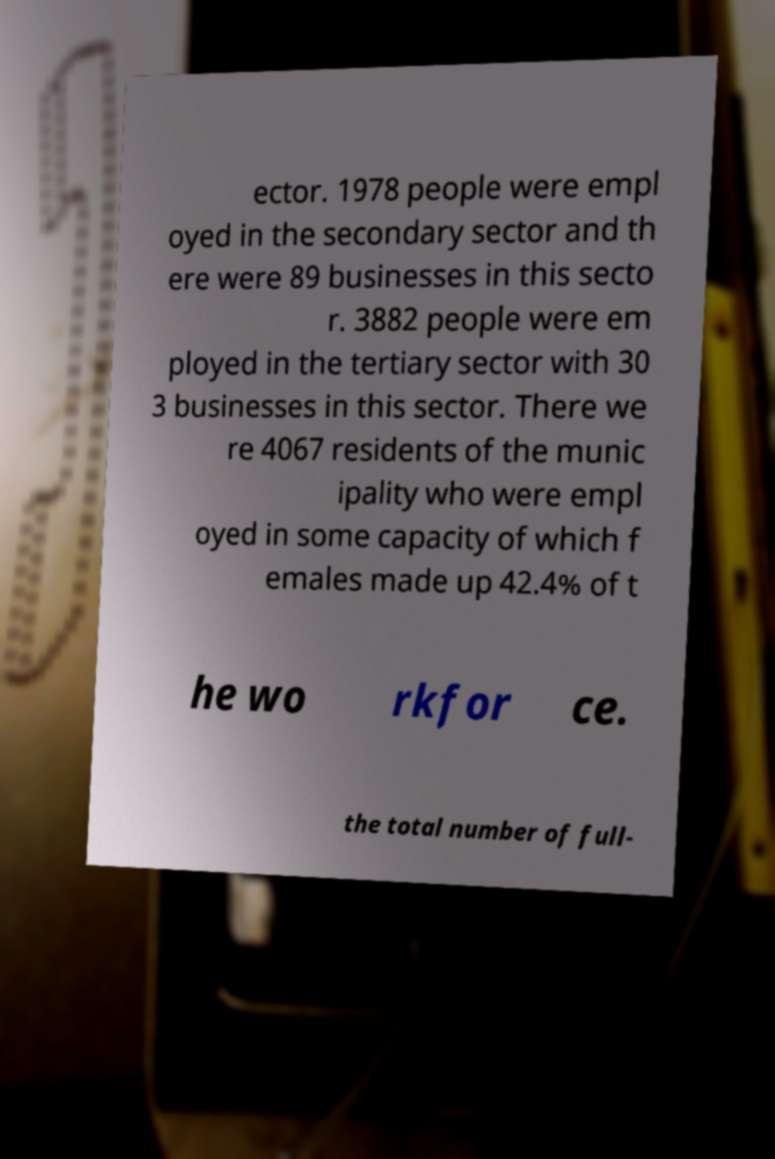I need the written content from this picture converted into text. Can you do that? ector. 1978 people were empl oyed in the secondary sector and th ere were 89 businesses in this secto r. 3882 people were em ployed in the tertiary sector with 30 3 businesses in this sector. There we re 4067 residents of the munic ipality who were empl oyed in some capacity of which f emales made up 42.4% of t he wo rkfor ce. the total number of full- 